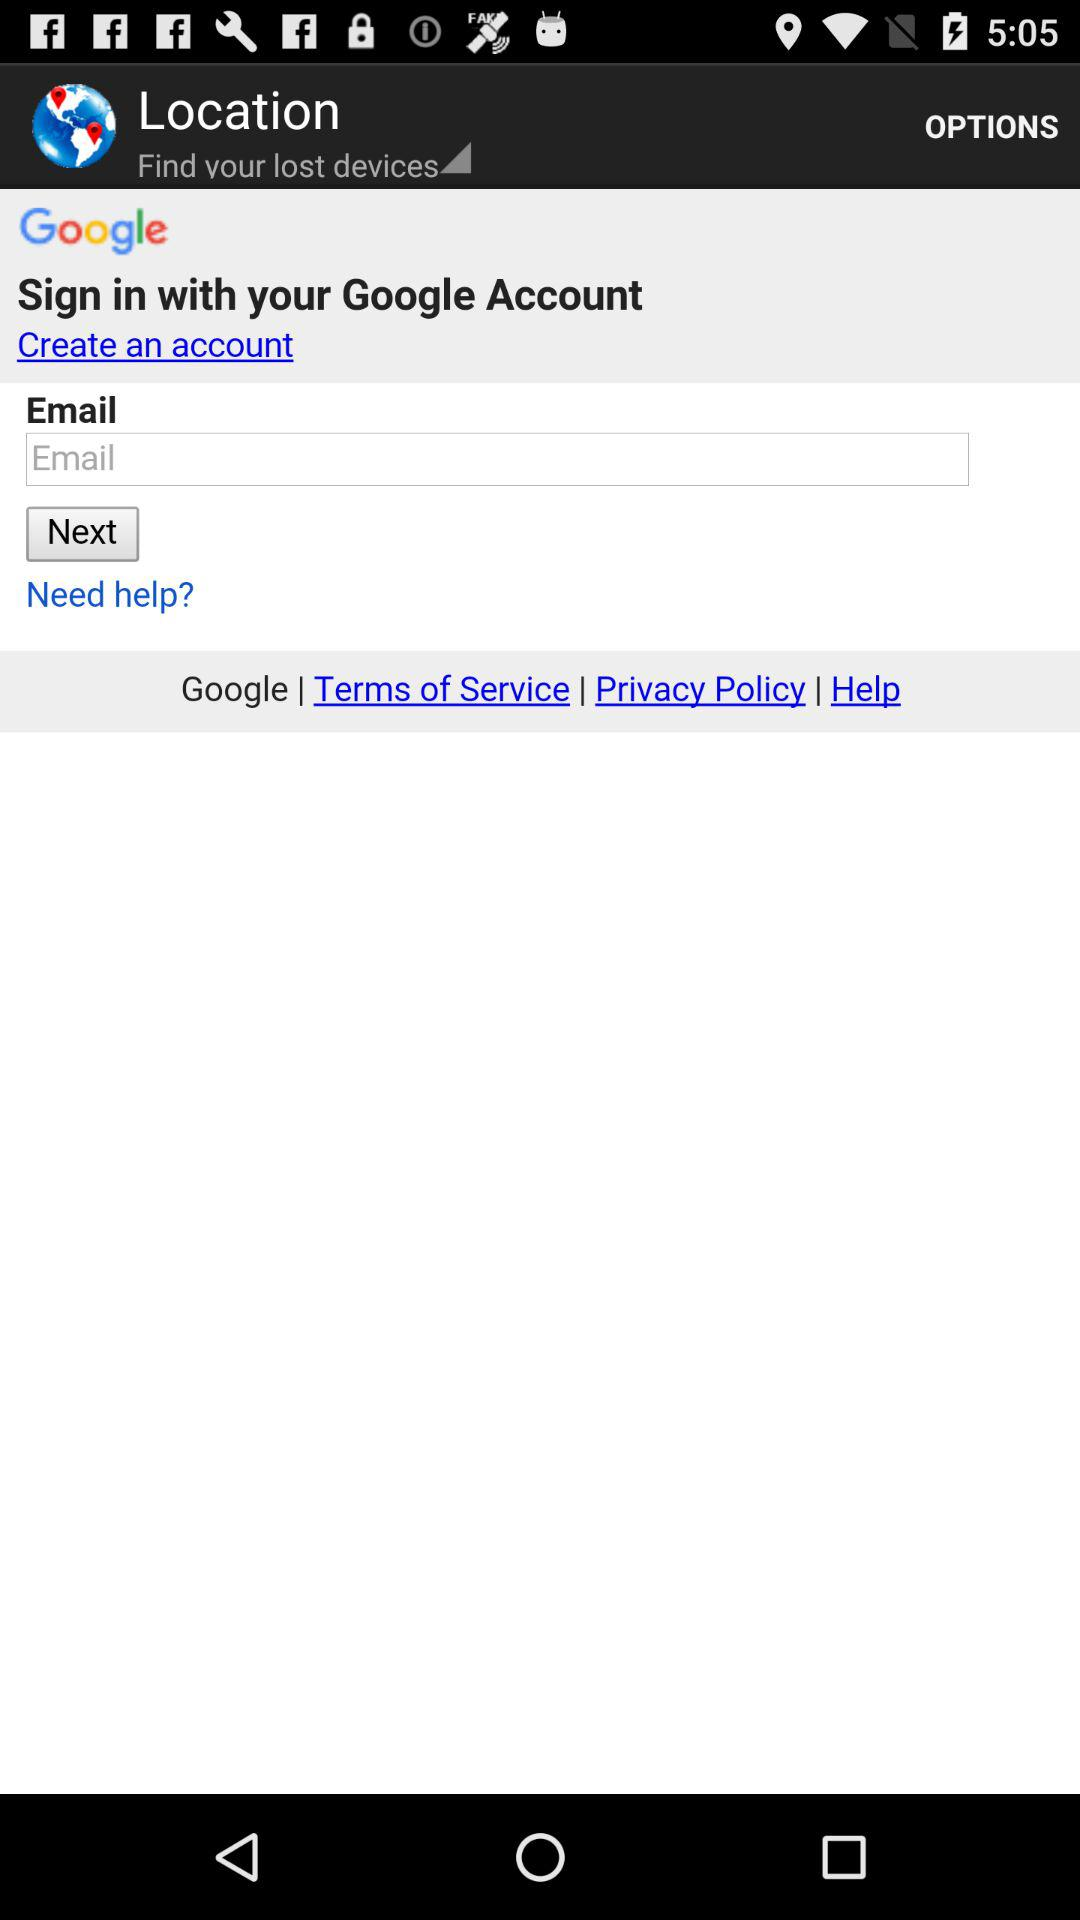What is the app name? The name of the app is "Location". 